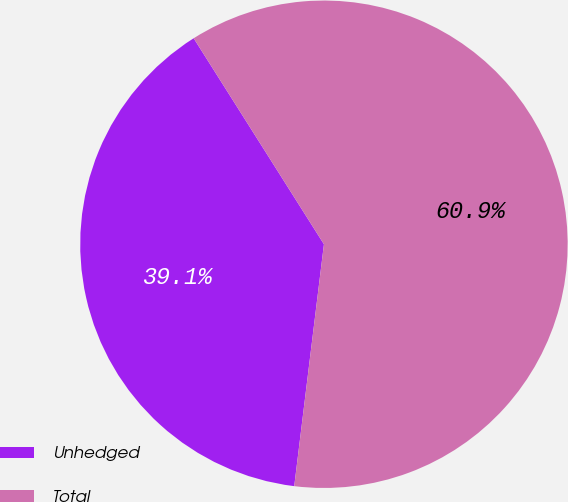<chart> <loc_0><loc_0><loc_500><loc_500><pie_chart><fcel>Unhedged<fcel>Total<nl><fcel>39.08%<fcel>60.92%<nl></chart> 